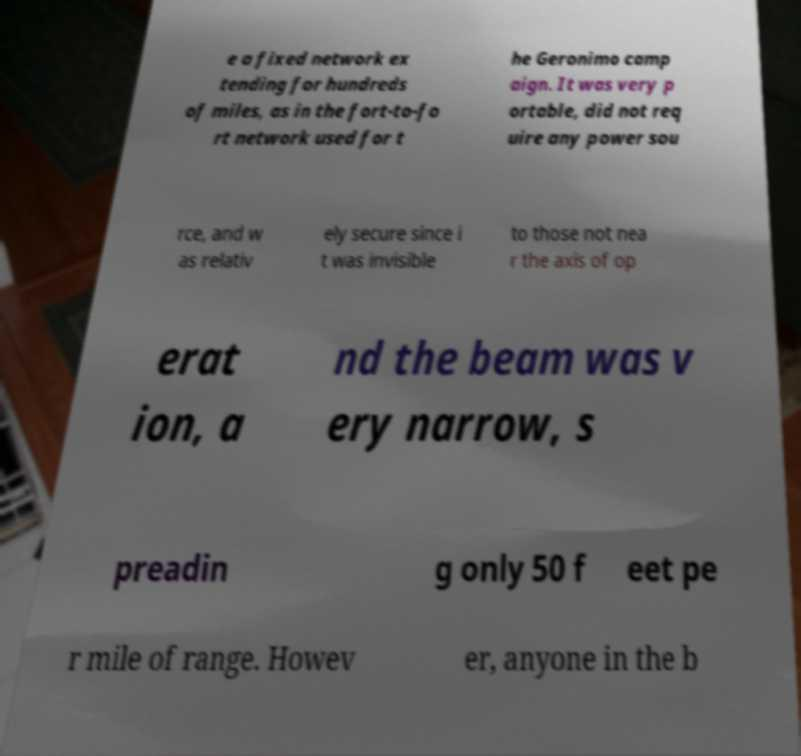Please read and relay the text visible in this image. What does it say? e a fixed network ex tending for hundreds of miles, as in the fort-to-fo rt network used for t he Geronimo camp aign. It was very p ortable, did not req uire any power sou rce, and w as relativ ely secure since i t was invisible to those not nea r the axis of op erat ion, a nd the beam was v ery narrow, s preadin g only 50 f eet pe r mile of range. Howev er, anyone in the b 